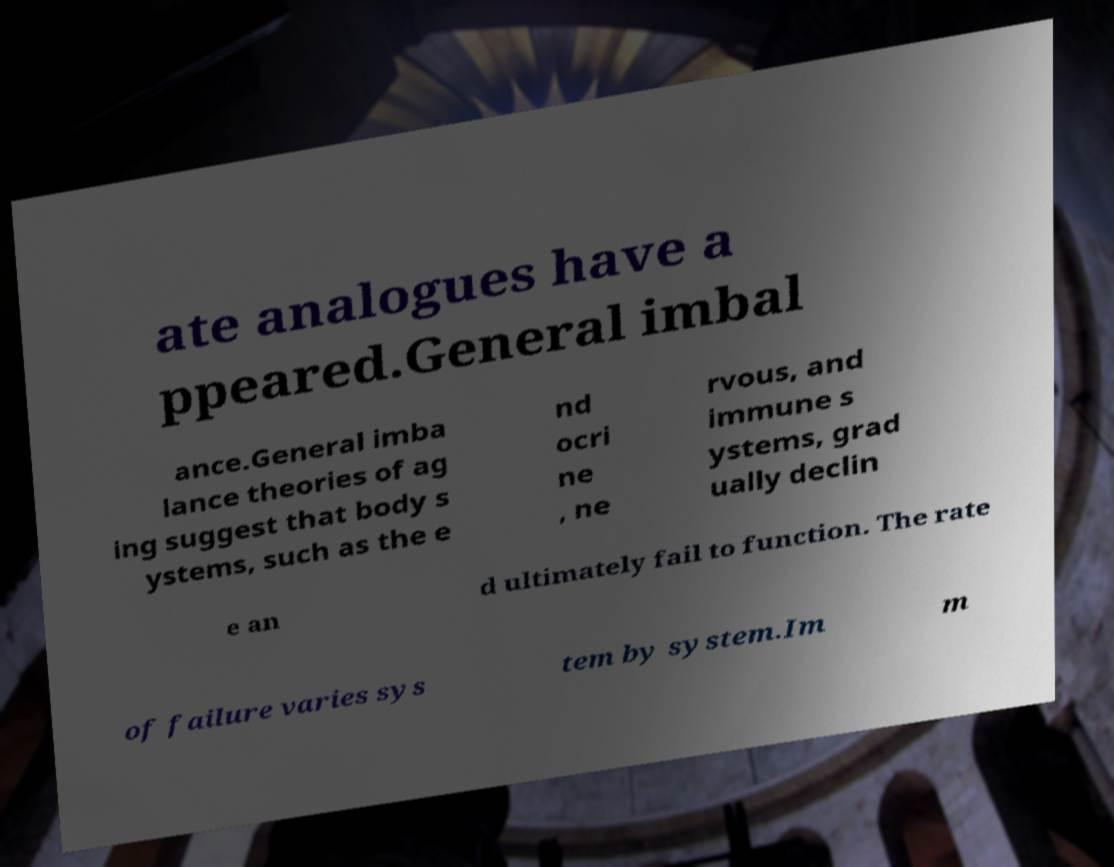Can you accurately transcribe the text from the provided image for me? ate analogues have a ppeared.General imbal ance.General imba lance theories of ag ing suggest that body s ystems, such as the e nd ocri ne , ne rvous, and immune s ystems, grad ually declin e an d ultimately fail to function. The rate of failure varies sys tem by system.Im m 